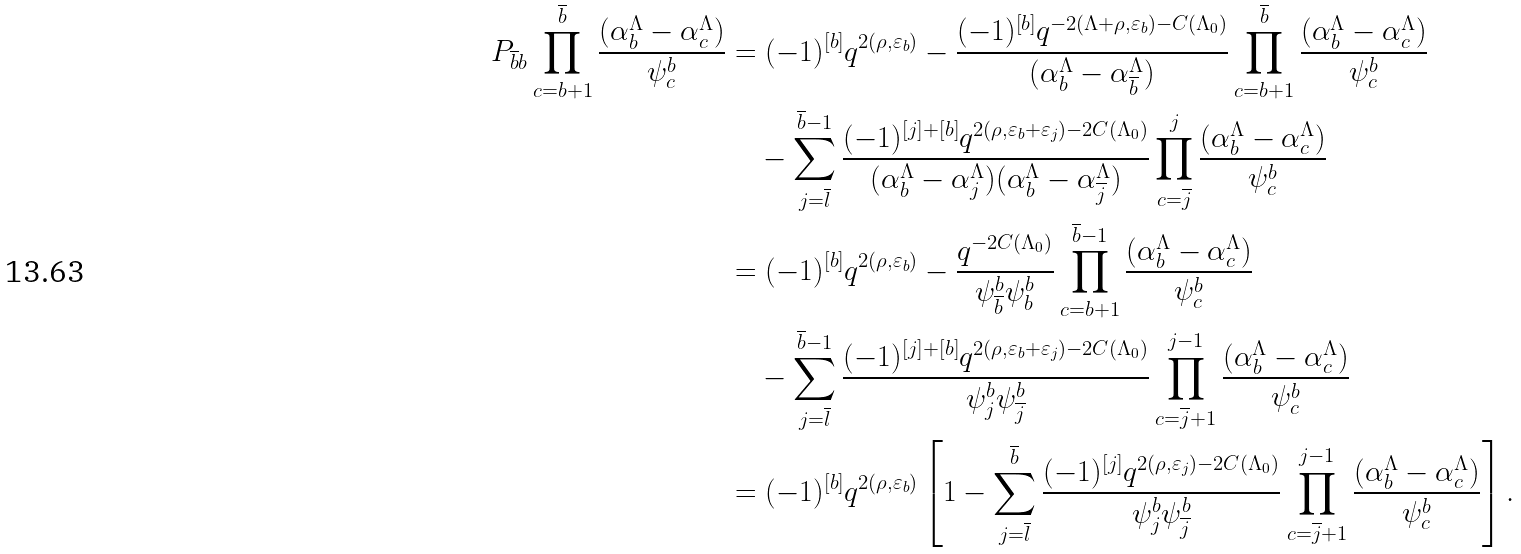<formula> <loc_0><loc_0><loc_500><loc_500>P _ { \overline { b } b } \prod _ { c = b + 1 } ^ { \overline { b } } \frac { ( \alpha _ { b } ^ { \Lambda } - \alpha _ { c } ^ { \Lambda } ) } { \psi ^ { b } _ { c } } & = ( - 1 ) ^ { [ b ] } q ^ { 2 ( \rho , \varepsilon _ { b } ) } - \frac { ( - 1 ) ^ { [ b ] } q ^ { - 2 ( \Lambda + \rho , \varepsilon _ { b } ) - C ( \Lambda _ { 0 } ) } } { ( \alpha _ { b } ^ { \Lambda } - \alpha _ { \overline { b } } ^ { \Lambda } ) } \prod _ { c = b + 1 } ^ { \overline { b } } \frac { ( \alpha _ { b } ^ { \Lambda } - \alpha _ { c } ^ { \Lambda } ) } { \psi ^ { b } _ { c } } \\ & \quad - \sum _ { j = \overline { l } } ^ { \overline { b } - 1 } \frac { ( - 1 ) ^ { [ j ] + [ b ] } q ^ { 2 ( \rho , \varepsilon _ { b } + \varepsilon _ { j } ) - 2 C ( \Lambda _ { 0 } ) } } { ( \alpha _ { b } ^ { \Lambda } - \alpha _ { j } ^ { \Lambda } ) ( \alpha _ { b } ^ { \Lambda } - \alpha _ { \overline { j } } ^ { \Lambda } ) } \prod _ { c = \overline { j } } ^ { j } \frac { ( \alpha _ { b } ^ { \Lambda } - \alpha _ { c } ^ { \Lambda } ) } { \psi ^ { b } _ { c } } \\ & = ( - 1 ) ^ { [ b ] } q ^ { 2 ( \rho , \varepsilon _ { b } ) } - \frac { q ^ { - 2 C ( \Lambda _ { 0 } ) } } { \psi ^ { b } _ { \overline { b } } \psi ^ { b } _ { b } } \prod _ { c = b + 1 } ^ { \overline { b } - 1 } \frac { ( \alpha _ { b } ^ { \Lambda } - \alpha _ { c } ^ { \Lambda } ) } { \psi ^ { b } _ { c } } \\ & \quad - \sum _ { j = \overline { l } } ^ { \overline { b } - 1 } \frac { ( - 1 ) ^ { [ j ] + [ b ] } q ^ { 2 ( \rho , \varepsilon _ { b } + \varepsilon _ { j } ) - 2 C ( \Lambda _ { 0 } ) } } { \psi ^ { b } _ { j } \psi ^ { b } _ { \overline { j } } } \prod _ { c = \overline { j } + 1 } ^ { j - 1 } \frac { ( \alpha _ { b } ^ { \Lambda } - \alpha _ { c } ^ { \Lambda } ) } { \psi ^ { b } _ { c } } \\ & = ( - 1 ) ^ { [ b ] } q ^ { 2 ( \rho , \varepsilon _ { b } ) } \left [ 1 - \sum _ { j = \overline { l } } ^ { \overline { b } } \frac { ( - 1 ) ^ { [ j ] } q ^ { 2 ( \rho , \varepsilon _ { j } ) - 2 C ( \Lambda _ { 0 } ) } } { \psi ^ { b } _ { j } \psi ^ { b } _ { \overline { j } } } \prod _ { c = \overline { j } + 1 } ^ { j - 1 } \frac { ( \alpha _ { b } ^ { \Lambda } - \alpha _ { c } ^ { \Lambda } ) } { \psi ^ { b } _ { c } } \right ] .</formula> 